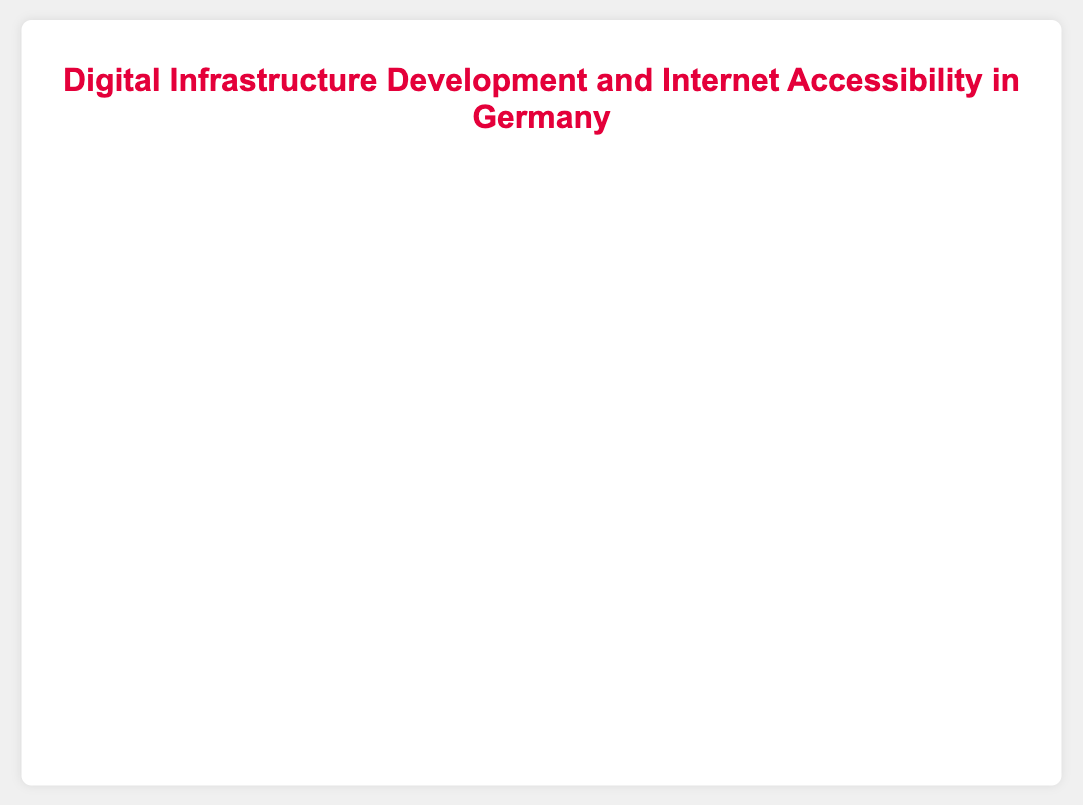Which region has the highest internet accessibility? We look at all the bubble points along the y-axis and identify the maximum internet accessibility value, which is 88.6% for Berlin.
Answer: Berlin How many regions have an internet accessibility above 80%? Checking the y-values of all points, we find that Bavaria, North Rhine-Westphalia, Hesse, Berlin, Hamburg, and Schleswig-Holstein all have internet accessibility values above 80%.
Answer: 6 Which region has the smallest population, and what are its digital infrastructure development and internet accessibility values? By examining the size of the bubbles (which represent population), the smallest bubble is Saarland. Saarland has 72.1% digital infrastructure development and 77.8% internet accessibility.
Answer: Saarland, 72.1%, 77.8% What is the difference in internet accessibility between the regions with the highest and lowest values? The highest internet accessibility is in Berlin (88.6%) and the lowest is in Saxony (75.2%). The difference is 88.6% - 75.2% = 13.4%.
Answer: 13.4% Compare the internet accessibility and digital infrastructure development between Bavaria and Baden-Württemberg. Which region is better in both aspects? Bavaria has 85.4% internet accessibility and 78.2% digital infrastructure development, while Baden-Württemberg has 80.1% internet accessibility and 76.3% digital infrastructure development. Bavaria is better in both aspects.
Answer: Bavaria What is the average digital infrastructure development in the top three regions with the highest internet accessibility? The top three regions by internet accessibility are Berlin (81.7%), Hamburg (80.4%), and Bavaria (78.2%). The average is (81.7 + 80.4 + 78.2) / 3 = 80.1%.
Answer: 80.1% For regions with a population below 5 million, which one has the highest digital infrastructure development? For populations below 5 million, the regions are Berlin, Hamburg, Schleswig-Holstein, and Saarland. Berlin has the highest digital infrastructure development at 81.7%.
Answer: Berlin Are there more regions above or below the median internet accessibility value, and what is that value? To find the median, we list internet accessibility values: 75.2, 77.8, 78.3, 79.5, 80.1, 82.0, 83.5, 85.4, 87.2, 88.6. The median value is the average of the 5th and 6th values: (80.1 + 82.0) / 2 = 81.05%. There are 5 regions below and 5 regions above the median.
Answer: Equal, 81.05% 